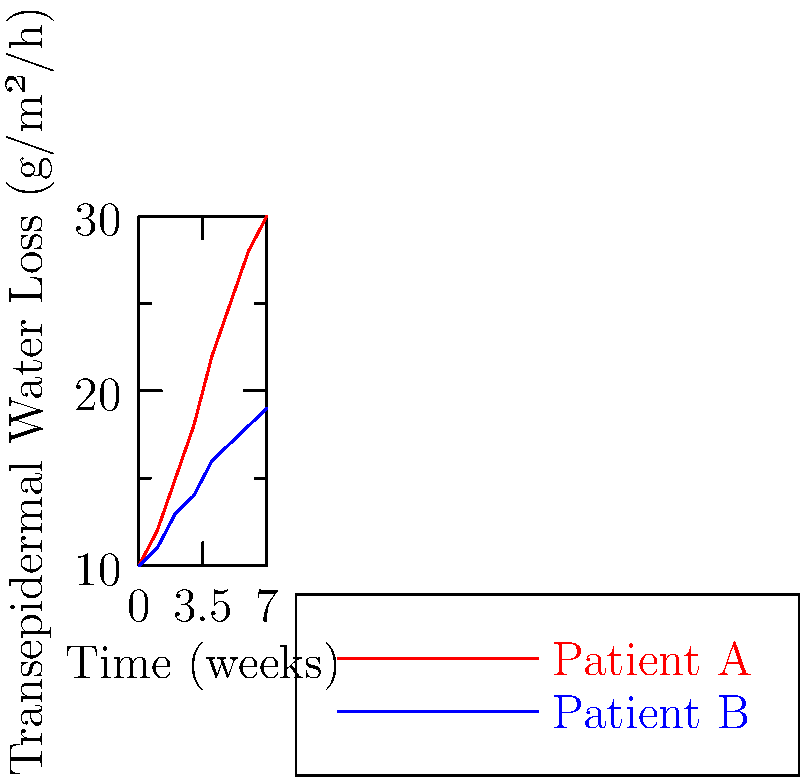Based on the line graph showing transepidermal water loss (TEWL) measurements over 7 weeks for two patients, which patient is more likely experiencing a decline in skin barrier function? To determine which patient is experiencing a decline in skin barrier function, we need to analyze the trends in transepidermal water loss (TEWL) measurements for both patients:

1. Patient A (red line):
   - Starting TEWL: 10 g/m²/h
   - Ending TEWL: 30 g/m²/h
   - Trend: Steep increase over time

2. Patient B (blue line):
   - Starting TEWL: 10 g/m²/h
   - Ending TEWL: 19 g/m²/h
   - Trend: Gradual increase over time

3. Interpretation of TEWL measurements:
   - Higher TEWL values indicate increased water loss through the skin
   - Increased water loss suggests a compromised skin barrier function

4. Comparison:
   - Patient A shows a more significant increase in TEWL (from 10 to 30 g/m²/h)
   - Patient B shows a milder increase in TEWL (from 10 to 19 g/m²/h)

5. Conclusion:
   The steeper increase in TEWL for Patient A indicates a more substantial decline in skin barrier function compared to Patient B.
Answer: Patient A 